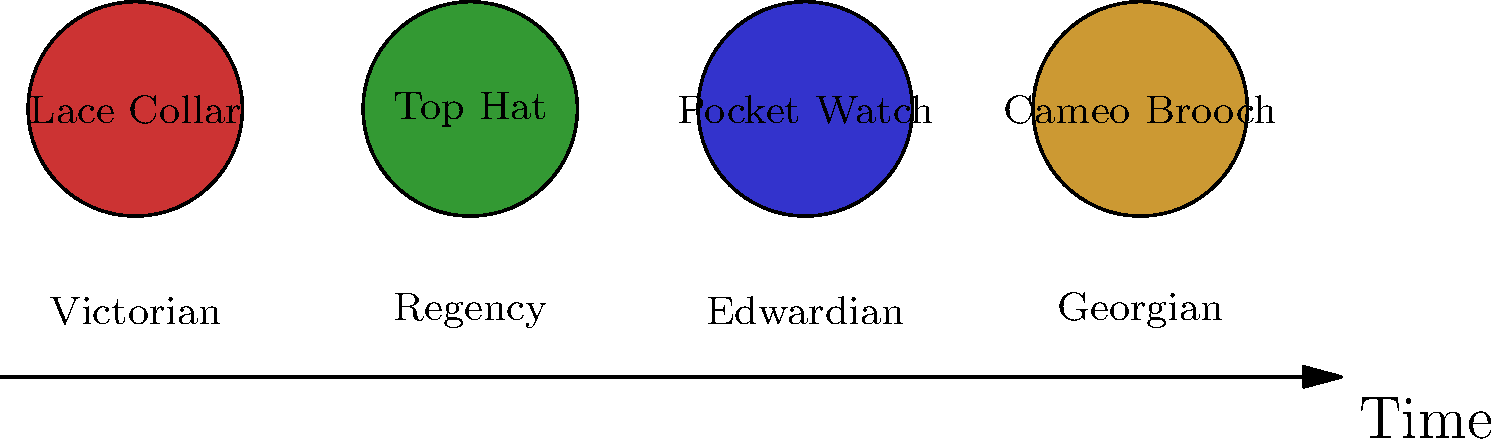Match the antique clothing accessories to their corresponding time periods based on the visual representation. Which accessory is most likely associated with the earliest time period shown? To answer this question, we need to analyze the timeline and the accessories shown:

1. The timeline shows four periods: Georgian, Regency, Victorian, and Edwardian, in chronological order from earliest to latest.

2. The accessories shown are:
   - Lace Collar
   - Top Hat
   - Pocket Watch
   - Cameo Brooch

3. Analyzing each accessory:
   - Lace Collars were popular in various periods but were particularly associated with the Victorian era.
   - Top Hats became fashionable during the Regency period and remained popular through the Victorian era.
   - Pocket Watches were used in all these periods but became widely popular during the Victorian era.
   - Cameo Brooches, while used in later periods, gained significant popularity during the Georgian era.

4. Among these options, the Georgian period is the earliest shown on the timeline.

5. The Cameo Brooch is most strongly associated with the Georgian period, which is the earliest of the four periods presented.

Therefore, the accessory most likely associated with the earliest time period shown is the Cameo Brooch.
Answer: Cameo Brooch 